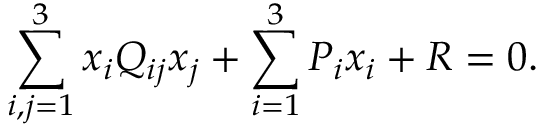<formula> <loc_0><loc_0><loc_500><loc_500>\sum _ { i , j = 1 } ^ { 3 } x _ { i } Q _ { i j } x _ { j } + \sum _ { i = 1 } ^ { 3 } P _ { i } x _ { i } + R = 0 .</formula> 